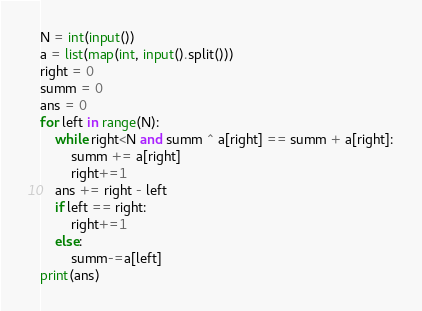<code> <loc_0><loc_0><loc_500><loc_500><_Python_>N = int(input())
a = list(map(int, input().split()))
right = 0
summ = 0
ans = 0
for left in range(N):
    while right<N and summ ^ a[right] == summ + a[right]:
        summ += a[right]
        right+=1
    ans += right - left
    if left == right:
        right+=1
    else:
        summ-=a[left]
print(ans)</code> 